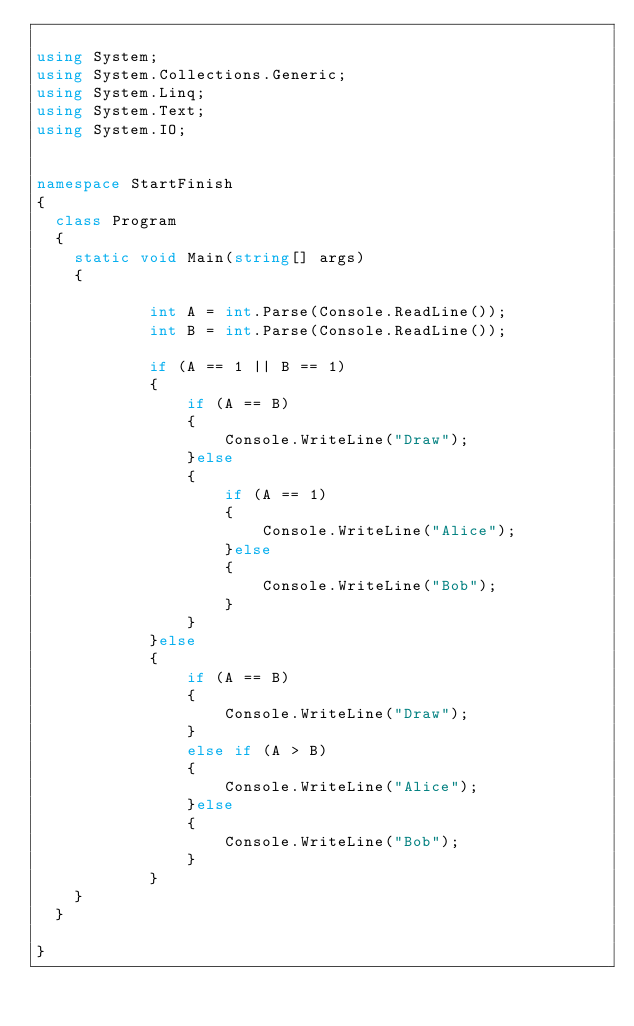<code> <loc_0><loc_0><loc_500><loc_500><_C#_>
using System;
using System.Collections.Generic;
using System.Linq;
using System.Text;
using System.IO;


namespace StartFinish
{
	class Program
	{
		static void Main(string[] args)
		{

            int A = int.Parse(Console.ReadLine());
            int B = int.Parse(Console.ReadLine());

            if (A == 1 || B == 1)
            {
                if (A == B)
                {
                    Console.WriteLine("Draw");
                }else
                {
                    if (A == 1)
                    {
                        Console.WriteLine("Alice");
                    }else
                    {
                        Console.WriteLine("Bob");
                    }
                }
            }else
            {
                if (A == B)
                {
                    Console.WriteLine("Draw");
                }
                else if (A > B)
                {
                    Console.WriteLine("Alice");
                }else
                {
                    Console.WriteLine("Bob");
                }
            }
		}
	}
	
}
</code> 